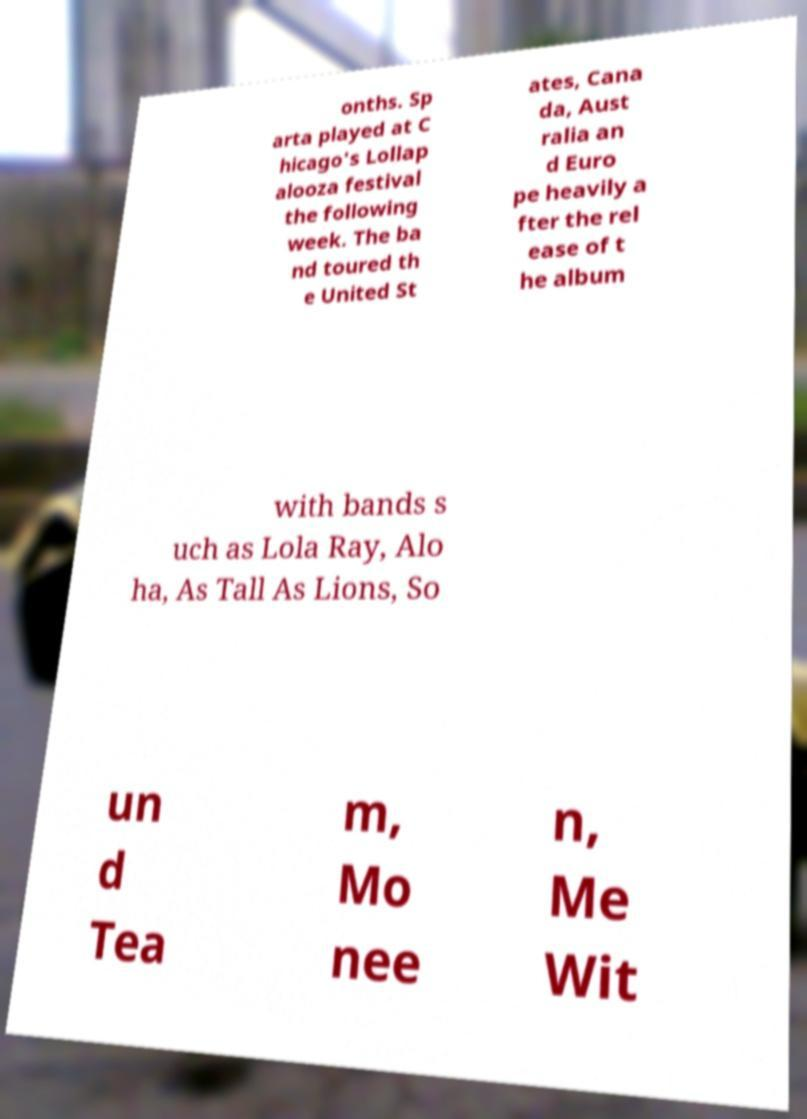I need the written content from this picture converted into text. Can you do that? onths. Sp arta played at C hicago's Lollap alooza festival the following week. The ba nd toured th e United St ates, Cana da, Aust ralia an d Euro pe heavily a fter the rel ease of t he album with bands s uch as Lola Ray, Alo ha, As Tall As Lions, So un d Tea m, Mo nee n, Me Wit 